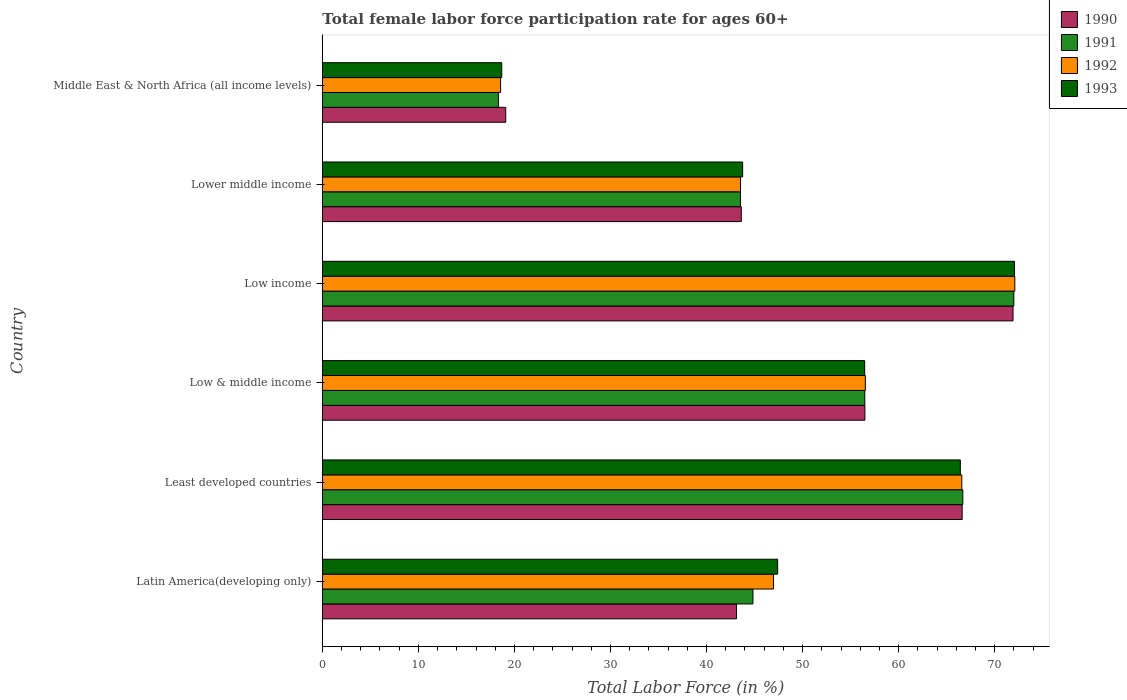How many groups of bars are there?
Keep it short and to the point. 6. Are the number of bars per tick equal to the number of legend labels?
Offer a very short reply. Yes. What is the label of the 5th group of bars from the top?
Offer a terse response. Least developed countries. What is the female labor force participation rate in 1992 in Lower middle income?
Keep it short and to the point. 43.54. Across all countries, what is the maximum female labor force participation rate in 1993?
Your answer should be very brief. 72.06. Across all countries, what is the minimum female labor force participation rate in 1993?
Keep it short and to the point. 18.68. In which country was the female labor force participation rate in 1993 maximum?
Your answer should be very brief. Low income. In which country was the female labor force participation rate in 1992 minimum?
Provide a short and direct response. Middle East & North Africa (all income levels). What is the total female labor force participation rate in 1990 in the graph?
Keep it short and to the point. 300.82. What is the difference between the female labor force participation rate in 1991 in Least developed countries and that in Middle East & North Africa (all income levels)?
Your answer should be compact. 48.35. What is the difference between the female labor force participation rate in 1992 in Latin America(developing only) and the female labor force participation rate in 1993 in Lower middle income?
Provide a short and direct response. 3.22. What is the average female labor force participation rate in 1992 per country?
Offer a terse response. 50.71. What is the difference between the female labor force participation rate in 1990 and female labor force participation rate in 1993 in Latin America(developing only)?
Give a very brief answer. -4.28. In how many countries, is the female labor force participation rate in 1993 greater than 20 %?
Provide a short and direct response. 5. What is the ratio of the female labor force participation rate in 1992 in Latin America(developing only) to that in Low income?
Your response must be concise. 0.65. Is the female labor force participation rate in 1992 in Lower middle income less than that in Middle East & North Africa (all income levels)?
Keep it short and to the point. No. Is the difference between the female labor force participation rate in 1990 in Lower middle income and Middle East & North Africa (all income levels) greater than the difference between the female labor force participation rate in 1993 in Lower middle income and Middle East & North Africa (all income levels)?
Provide a succinct answer. No. What is the difference between the highest and the second highest female labor force participation rate in 1992?
Offer a terse response. 5.52. What is the difference between the highest and the lowest female labor force participation rate in 1993?
Your answer should be compact. 53.38. In how many countries, is the female labor force participation rate in 1992 greater than the average female labor force participation rate in 1992 taken over all countries?
Offer a very short reply. 3. What does the 3rd bar from the top in Low income represents?
Provide a short and direct response. 1991. What does the 4th bar from the bottom in Low & middle income represents?
Offer a very short reply. 1993. How many bars are there?
Give a very brief answer. 24. What is the difference between two consecutive major ticks on the X-axis?
Ensure brevity in your answer.  10. Does the graph contain grids?
Make the answer very short. No. Where does the legend appear in the graph?
Ensure brevity in your answer.  Top right. How many legend labels are there?
Provide a succinct answer. 4. How are the legend labels stacked?
Keep it short and to the point. Vertical. What is the title of the graph?
Provide a succinct answer. Total female labor force participation rate for ages 60+. Does "2010" appear as one of the legend labels in the graph?
Ensure brevity in your answer.  No. What is the label or title of the X-axis?
Keep it short and to the point. Total Labor Force (in %). What is the Total Labor Force (in %) of 1990 in Latin America(developing only)?
Your answer should be very brief. 43.12. What is the Total Labor Force (in %) of 1991 in Latin America(developing only)?
Your response must be concise. 44.83. What is the Total Labor Force (in %) of 1992 in Latin America(developing only)?
Your answer should be very brief. 46.97. What is the Total Labor Force (in %) in 1993 in Latin America(developing only)?
Give a very brief answer. 47.4. What is the Total Labor Force (in %) of 1990 in Least developed countries?
Give a very brief answer. 66.61. What is the Total Labor Force (in %) of 1991 in Least developed countries?
Offer a terse response. 66.68. What is the Total Labor Force (in %) of 1992 in Least developed countries?
Provide a succinct answer. 66.57. What is the Total Labor Force (in %) in 1993 in Least developed countries?
Give a very brief answer. 66.42. What is the Total Labor Force (in %) in 1990 in Low & middle income?
Give a very brief answer. 56.48. What is the Total Labor Force (in %) in 1991 in Low & middle income?
Offer a very short reply. 56.47. What is the Total Labor Force (in %) of 1992 in Low & middle income?
Provide a short and direct response. 56.53. What is the Total Labor Force (in %) in 1993 in Low & middle income?
Offer a terse response. 56.46. What is the Total Labor Force (in %) of 1990 in Low income?
Your answer should be very brief. 71.9. What is the Total Labor Force (in %) of 1991 in Low income?
Provide a short and direct response. 71.99. What is the Total Labor Force (in %) in 1992 in Low income?
Offer a very short reply. 72.09. What is the Total Labor Force (in %) of 1993 in Low income?
Your answer should be compact. 72.06. What is the Total Labor Force (in %) in 1990 in Lower middle income?
Offer a terse response. 43.62. What is the Total Labor Force (in %) in 1991 in Lower middle income?
Your answer should be very brief. 43.53. What is the Total Labor Force (in %) in 1992 in Lower middle income?
Ensure brevity in your answer.  43.54. What is the Total Labor Force (in %) of 1993 in Lower middle income?
Keep it short and to the point. 43.76. What is the Total Labor Force (in %) in 1990 in Middle East & North Africa (all income levels)?
Your answer should be very brief. 19.09. What is the Total Labor Force (in %) of 1991 in Middle East & North Africa (all income levels)?
Provide a short and direct response. 18.33. What is the Total Labor Force (in %) of 1992 in Middle East & North Africa (all income levels)?
Ensure brevity in your answer.  18.56. What is the Total Labor Force (in %) in 1993 in Middle East & North Africa (all income levels)?
Your response must be concise. 18.68. Across all countries, what is the maximum Total Labor Force (in %) in 1990?
Your answer should be compact. 71.9. Across all countries, what is the maximum Total Labor Force (in %) of 1991?
Your answer should be compact. 71.99. Across all countries, what is the maximum Total Labor Force (in %) of 1992?
Give a very brief answer. 72.09. Across all countries, what is the maximum Total Labor Force (in %) in 1993?
Your answer should be compact. 72.06. Across all countries, what is the minimum Total Labor Force (in %) in 1990?
Offer a terse response. 19.09. Across all countries, what is the minimum Total Labor Force (in %) of 1991?
Provide a short and direct response. 18.33. Across all countries, what is the minimum Total Labor Force (in %) of 1992?
Provide a succinct answer. 18.56. Across all countries, what is the minimum Total Labor Force (in %) of 1993?
Offer a terse response. 18.68. What is the total Total Labor Force (in %) of 1990 in the graph?
Ensure brevity in your answer.  300.82. What is the total Total Labor Force (in %) of 1991 in the graph?
Ensure brevity in your answer.  301.83. What is the total Total Labor Force (in %) of 1992 in the graph?
Ensure brevity in your answer.  304.26. What is the total Total Labor Force (in %) in 1993 in the graph?
Give a very brief answer. 304.77. What is the difference between the Total Labor Force (in %) in 1990 in Latin America(developing only) and that in Least developed countries?
Ensure brevity in your answer.  -23.49. What is the difference between the Total Labor Force (in %) of 1991 in Latin America(developing only) and that in Least developed countries?
Provide a succinct answer. -21.85. What is the difference between the Total Labor Force (in %) of 1992 in Latin America(developing only) and that in Least developed countries?
Give a very brief answer. -19.6. What is the difference between the Total Labor Force (in %) of 1993 in Latin America(developing only) and that in Least developed countries?
Give a very brief answer. -19.02. What is the difference between the Total Labor Force (in %) of 1990 in Latin America(developing only) and that in Low & middle income?
Your answer should be compact. -13.36. What is the difference between the Total Labor Force (in %) in 1991 in Latin America(developing only) and that in Low & middle income?
Your response must be concise. -11.64. What is the difference between the Total Labor Force (in %) of 1992 in Latin America(developing only) and that in Low & middle income?
Keep it short and to the point. -9.56. What is the difference between the Total Labor Force (in %) in 1993 in Latin America(developing only) and that in Low & middle income?
Your answer should be very brief. -9.06. What is the difference between the Total Labor Force (in %) of 1990 in Latin America(developing only) and that in Low income?
Make the answer very short. -28.78. What is the difference between the Total Labor Force (in %) of 1991 in Latin America(developing only) and that in Low income?
Ensure brevity in your answer.  -27.16. What is the difference between the Total Labor Force (in %) in 1992 in Latin America(developing only) and that in Low income?
Ensure brevity in your answer.  -25.12. What is the difference between the Total Labor Force (in %) of 1993 in Latin America(developing only) and that in Low income?
Provide a short and direct response. -24.66. What is the difference between the Total Labor Force (in %) in 1990 in Latin America(developing only) and that in Lower middle income?
Make the answer very short. -0.5. What is the difference between the Total Labor Force (in %) of 1991 in Latin America(developing only) and that in Lower middle income?
Provide a short and direct response. 1.3. What is the difference between the Total Labor Force (in %) in 1992 in Latin America(developing only) and that in Lower middle income?
Make the answer very short. 3.44. What is the difference between the Total Labor Force (in %) of 1993 in Latin America(developing only) and that in Lower middle income?
Keep it short and to the point. 3.64. What is the difference between the Total Labor Force (in %) of 1990 in Latin America(developing only) and that in Middle East & North Africa (all income levels)?
Make the answer very short. 24.03. What is the difference between the Total Labor Force (in %) of 1991 in Latin America(developing only) and that in Middle East & North Africa (all income levels)?
Give a very brief answer. 26.5. What is the difference between the Total Labor Force (in %) of 1992 in Latin America(developing only) and that in Middle East & North Africa (all income levels)?
Your answer should be very brief. 28.42. What is the difference between the Total Labor Force (in %) of 1993 in Latin America(developing only) and that in Middle East & North Africa (all income levels)?
Provide a short and direct response. 28.72. What is the difference between the Total Labor Force (in %) in 1990 in Least developed countries and that in Low & middle income?
Make the answer very short. 10.12. What is the difference between the Total Labor Force (in %) in 1991 in Least developed countries and that in Low & middle income?
Your answer should be compact. 10.21. What is the difference between the Total Labor Force (in %) of 1992 in Least developed countries and that in Low & middle income?
Offer a terse response. 10.04. What is the difference between the Total Labor Force (in %) in 1993 in Least developed countries and that in Low & middle income?
Your answer should be very brief. 9.96. What is the difference between the Total Labor Force (in %) of 1990 in Least developed countries and that in Low income?
Provide a short and direct response. -5.3. What is the difference between the Total Labor Force (in %) in 1991 in Least developed countries and that in Low income?
Give a very brief answer. -5.31. What is the difference between the Total Labor Force (in %) in 1992 in Least developed countries and that in Low income?
Offer a terse response. -5.52. What is the difference between the Total Labor Force (in %) in 1993 in Least developed countries and that in Low income?
Your answer should be compact. -5.64. What is the difference between the Total Labor Force (in %) in 1990 in Least developed countries and that in Lower middle income?
Make the answer very short. 22.99. What is the difference between the Total Labor Force (in %) in 1991 in Least developed countries and that in Lower middle income?
Give a very brief answer. 23.15. What is the difference between the Total Labor Force (in %) in 1992 in Least developed countries and that in Lower middle income?
Offer a terse response. 23.04. What is the difference between the Total Labor Force (in %) in 1993 in Least developed countries and that in Lower middle income?
Offer a very short reply. 22.66. What is the difference between the Total Labor Force (in %) in 1990 in Least developed countries and that in Middle East & North Africa (all income levels)?
Give a very brief answer. 47.52. What is the difference between the Total Labor Force (in %) of 1991 in Least developed countries and that in Middle East & North Africa (all income levels)?
Keep it short and to the point. 48.35. What is the difference between the Total Labor Force (in %) of 1992 in Least developed countries and that in Middle East & North Africa (all income levels)?
Make the answer very short. 48.02. What is the difference between the Total Labor Force (in %) of 1993 in Least developed countries and that in Middle East & North Africa (all income levels)?
Provide a short and direct response. 47.74. What is the difference between the Total Labor Force (in %) in 1990 in Low & middle income and that in Low income?
Ensure brevity in your answer.  -15.42. What is the difference between the Total Labor Force (in %) of 1991 in Low & middle income and that in Low income?
Offer a very short reply. -15.52. What is the difference between the Total Labor Force (in %) in 1992 in Low & middle income and that in Low income?
Provide a short and direct response. -15.56. What is the difference between the Total Labor Force (in %) in 1993 in Low & middle income and that in Low income?
Your response must be concise. -15.6. What is the difference between the Total Labor Force (in %) of 1990 in Low & middle income and that in Lower middle income?
Your answer should be compact. 12.87. What is the difference between the Total Labor Force (in %) in 1991 in Low & middle income and that in Lower middle income?
Ensure brevity in your answer.  12.94. What is the difference between the Total Labor Force (in %) of 1992 in Low & middle income and that in Lower middle income?
Ensure brevity in your answer.  12.99. What is the difference between the Total Labor Force (in %) of 1993 in Low & middle income and that in Lower middle income?
Give a very brief answer. 12.7. What is the difference between the Total Labor Force (in %) of 1990 in Low & middle income and that in Middle East & North Africa (all income levels)?
Ensure brevity in your answer.  37.39. What is the difference between the Total Labor Force (in %) in 1991 in Low & middle income and that in Middle East & North Africa (all income levels)?
Your answer should be very brief. 38.14. What is the difference between the Total Labor Force (in %) of 1992 in Low & middle income and that in Middle East & North Africa (all income levels)?
Provide a short and direct response. 37.97. What is the difference between the Total Labor Force (in %) in 1993 in Low & middle income and that in Middle East & North Africa (all income levels)?
Offer a terse response. 37.78. What is the difference between the Total Labor Force (in %) in 1990 in Low income and that in Lower middle income?
Keep it short and to the point. 28.29. What is the difference between the Total Labor Force (in %) of 1991 in Low income and that in Lower middle income?
Your response must be concise. 28.46. What is the difference between the Total Labor Force (in %) in 1992 in Low income and that in Lower middle income?
Offer a terse response. 28.55. What is the difference between the Total Labor Force (in %) of 1993 in Low income and that in Lower middle income?
Offer a very short reply. 28.3. What is the difference between the Total Labor Force (in %) of 1990 in Low income and that in Middle East & North Africa (all income levels)?
Make the answer very short. 52.81. What is the difference between the Total Labor Force (in %) in 1991 in Low income and that in Middle East & North Africa (all income levels)?
Your answer should be compact. 53.66. What is the difference between the Total Labor Force (in %) in 1992 in Low income and that in Middle East & North Africa (all income levels)?
Give a very brief answer. 53.53. What is the difference between the Total Labor Force (in %) of 1993 in Low income and that in Middle East & North Africa (all income levels)?
Offer a very short reply. 53.38. What is the difference between the Total Labor Force (in %) in 1990 in Lower middle income and that in Middle East & North Africa (all income levels)?
Offer a terse response. 24.53. What is the difference between the Total Labor Force (in %) of 1991 in Lower middle income and that in Middle East & North Africa (all income levels)?
Offer a terse response. 25.2. What is the difference between the Total Labor Force (in %) of 1992 in Lower middle income and that in Middle East & North Africa (all income levels)?
Provide a succinct answer. 24.98. What is the difference between the Total Labor Force (in %) of 1993 in Lower middle income and that in Middle East & North Africa (all income levels)?
Give a very brief answer. 25.08. What is the difference between the Total Labor Force (in %) of 1990 in Latin America(developing only) and the Total Labor Force (in %) of 1991 in Least developed countries?
Make the answer very short. -23.56. What is the difference between the Total Labor Force (in %) of 1990 in Latin America(developing only) and the Total Labor Force (in %) of 1992 in Least developed countries?
Your answer should be compact. -23.45. What is the difference between the Total Labor Force (in %) of 1990 in Latin America(developing only) and the Total Labor Force (in %) of 1993 in Least developed countries?
Ensure brevity in your answer.  -23.3. What is the difference between the Total Labor Force (in %) in 1991 in Latin America(developing only) and the Total Labor Force (in %) in 1992 in Least developed countries?
Offer a terse response. -21.74. What is the difference between the Total Labor Force (in %) in 1991 in Latin America(developing only) and the Total Labor Force (in %) in 1993 in Least developed countries?
Keep it short and to the point. -21.59. What is the difference between the Total Labor Force (in %) of 1992 in Latin America(developing only) and the Total Labor Force (in %) of 1993 in Least developed countries?
Your answer should be compact. -19.45. What is the difference between the Total Labor Force (in %) of 1990 in Latin America(developing only) and the Total Labor Force (in %) of 1991 in Low & middle income?
Offer a very short reply. -13.35. What is the difference between the Total Labor Force (in %) of 1990 in Latin America(developing only) and the Total Labor Force (in %) of 1992 in Low & middle income?
Make the answer very short. -13.41. What is the difference between the Total Labor Force (in %) in 1990 in Latin America(developing only) and the Total Labor Force (in %) in 1993 in Low & middle income?
Your response must be concise. -13.34. What is the difference between the Total Labor Force (in %) of 1991 in Latin America(developing only) and the Total Labor Force (in %) of 1992 in Low & middle income?
Your answer should be very brief. -11.7. What is the difference between the Total Labor Force (in %) of 1991 in Latin America(developing only) and the Total Labor Force (in %) of 1993 in Low & middle income?
Offer a very short reply. -11.63. What is the difference between the Total Labor Force (in %) of 1992 in Latin America(developing only) and the Total Labor Force (in %) of 1993 in Low & middle income?
Your answer should be compact. -9.49. What is the difference between the Total Labor Force (in %) in 1990 in Latin America(developing only) and the Total Labor Force (in %) in 1991 in Low income?
Your response must be concise. -28.87. What is the difference between the Total Labor Force (in %) in 1990 in Latin America(developing only) and the Total Labor Force (in %) in 1992 in Low income?
Keep it short and to the point. -28.97. What is the difference between the Total Labor Force (in %) in 1990 in Latin America(developing only) and the Total Labor Force (in %) in 1993 in Low income?
Ensure brevity in your answer.  -28.94. What is the difference between the Total Labor Force (in %) in 1991 in Latin America(developing only) and the Total Labor Force (in %) in 1992 in Low income?
Provide a succinct answer. -27.26. What is the difference between the Total Labor Force (in %) in 1991 in Latin America(developing only) and the Total Labor Force (in %) in 1993 in Low income?
Provide a succinct answer. -27.23. What is the difference between the Total Labor Force (in %) of 1992 in Latin America(developing only) and the Total Labor Force (in %) of 1993 in Low income?
Offer a very short reply. -25.09. What is the difference between the Total Labor Force (in %) in 1990 in Latin America(developing only) and the Total Labor Force (in %) in 1991 in Lower middle income?
Provide a short and direct response. -0.41. What is the difference between the Total Labor Force (in %) in 1990 in Latin America(developing only) and the Total Labor Force (in %) in 1992 in Lower middle income?
Make the answer very short. -0.42. What is the difference between the Total Labor Force (in %) of 1990 in Latin America(developing only) and the Total Labor Force (in %) of 1993 in Lower middle income?
Ensure brevity in your answer.  -0.64. What is the difference between the Total Labor Force (in %) in 1991 in Latin America(developing only) and the Total Labor Force (in %) in 1992 in Lower middle income?
Your answer should be compact. 1.29. What is the difference between the Total Labor Force (in %) of 1991 in Latin America(developing only) and the Total Labor Force (in %) of 1993 in Lower middle income?
Your response must be concise. 1.07. What is the difference between the Total Labor Force (in %) of 1992 in Latin America(developing only) and the Total Labor Force (in %) of 1993 in Lower middle income?
Offer a very short reply. 3.22. What is the difference between the Total Labor Force (in %) of 1990 in Latin America(developing only) and the Total Labor Force (in %) of 1991 in Middle East & North Africa (all income levels)?
Offer a very short reply. 24.79. What is the difference between the Total Labor Force (in %) of 1990 in Latin America(developing only) and the Total Labor Force (in %) of 1992 in Middle East & North Africa (all income levels)?
Your response must be concise. 24.56. What is the difference between the Total Labor Force (in %) in 1990 in Latin America(developing only) and the Total Labor Force (in %) in 1993 in Middle East & North Africa (all income levels)?
Provide a short and direct response. 24.44. What is the difference between the Total Labor Force (in %) of 1991 in Latin America(developing only) and the Total Labor Force (in %) of 1992 in Middle East & North Africa (all income levels)?
Provide a succinct answer. 26.27. What is the difference between the Total Labor Force (in %) of 1991 in Latin America(developing only) and the Total Labor Force (in %) of 1993 in Middle East & North Africa (all income levels)?
Keep it short and to the point. 26.15. What is the difference between the Total Labor Force (in %) in 1992 in Latin America(developing only) and the Total Labor Force (in %) in 1993 in Middle East & North Africa (all income levels)?
Keep it short and to the point. 28.3. What is the difference between the Total Labor Force (in %) of 1990 in Least developed countries and the Total Labor Force (in %) of 1991 in Low & middle income?
Your answer should be very brief. 10.14. What is the difference between the Total Labor Force (in %) in 1990 in Least developed countries and the Total Labor Force (in %) in 1992 in Low & middle income?
Make the answer very short. 10.08. What is the difference between the Total Labor Force (in %) in 1990 in Least developed countries and the Total Labor Force (in %) in 1993 in Low & middle income?
Keep it short and to the point. 10.15. What is the difference between the Total Labor Force (in %) of 1991 in Least developed countries and the Total Labor Force (in %) of 1992 in Low & middle income?
Your answer should be compact. 10.15. What is the difference between the Total Labor Force (in %) in 1991 in Least developed countries and the Total Labor Force (in %) in 1993 in Low & middle income?
Your response must be concise. 10.22. What is the difference between the Total Labor Force (in %) of 1992 in Least developed countries and the Total Labor Force (in %) of 1993 in Low & middle income?
Make the answer very short. 10.11. What is the difference between the Total Labor Force (in %) of 1990 in Least developed countries and the Total Labor Force (in %) of 1991 in Low income?
Ensure brevity in your answer.  -5.38. What is the difference between the Total Labor Force (in %) of 1990 in Least developed countries and the Total Labor Force (in %) of 1992 in Low income?
Ensure brevity in your answer.  -5.48. What is the difference between the Total Labor Force (in %) of 1990 in Least developed countries and the Total Labor Force (in %) of 1993 in Low income?
Make the answer very short. -5.45. What is the difference between the Total Labor Force (in %) of 1991 in Least developed countries and the Total Labor Force (in %) of 1992 in Low income?
Your response must be concise. -5.41. What is the difference between the Total Labor Force (in %) in 1991 in Least developed countries and the Total Labor Force (in %) in 1993 in Low income?
Your answer should be compact. -5.38. What is the difference between the Total Labor Force (in %) in 1992 in Least developed countries and the Total Labor Force (in %) in 1993 in Low income?
Offer a terse response. -5.49. What is the difference between the Total Labor Force (in %) in 1990 in Least developed countries and the Total Labor Force (in %) in 1991 in Lower middle income?
Your answer should be very brief. 23.08. What is the difference between the Total Labor Force (in %) in 1990 in Least developed countries and the Total Labor Force (in %) in 1992 in Lower middle income?
Your answer should be very brief. 23.07. What is the difference between the Total Labor Force (in %) of 1990 in Least developed countries and the Total Labor Force (in %) of 1993 in Lower middle income?
Make the answer very short. 22.85. What is the difference between the Total Labor Force (in %) of 1991 in Least developed countries and the Total Labor Force (in %) of 1992 in Lower middle income?
Make the answer very short. 23.14. What is the difference between the Total Labor Force (in %) in 1991 in Least developed countries and the Total Labor Force (in %) in 1993 in Lower middle income?
Your answer should be compact. 22.92. What is the difference between the Total Labor Force (in %) in 1992 in Least developed countries and the Total Labor Force (in %) in 1993 in Lower middle income?
Provide a succinct answer. 22.82. What is the difference between the Total Labor Force (in %) in 1990 in Least developed countries and the Total Labor Force (in %) in 1991 in Middle East & North Africa (all income levels)?
Offer a terse response. 48.28. What is the difference between the Total Labor Force (in %) of 1990 in Least developed countries and the Total Labor Force (in %) of 1992 in Middle East & North Africa (all income levels)?
Ensure brevity in your answer.  48.05. What is the difference between the Total Labor Force (in %) in 1990 in Least developed countries and the Total Labor Force (in %) in 1993 in Middle East & North Africa (all income levels)?
Ensure brevity in your answer.  47.93. What is the difference between the Total Labor Force (in %) in 1991 in Least developed countries and the Total Labor Force (in %) in 1992 in Middle East & North Africa (all income levels)?
Offer a very short reply. 48.12. What is the difference between the Total Labor Force (in %) in 1991 in Least developed countries and the Total Labor Force (in %) in 1993 in Middle East & North Africa (all income levels)?
Your answer should be compact. 48. What is the difference between the Total Labor Force (in %) in 1992 in Least developed countries and the Total Labor Force (in %) in 1993 in Middle East & North Africa (all income levels)?
Your answer should be very brief. 47.9. What is the difference between the Total Labor Force (in %) of 1990 in Low & middle income and the Total Labor Force (in %) of 1991 in Low income?
Offer a terse response. -15.51. What is the difference between the Total Labor Force (in %) of 1990 in Low & middle income and the Total Labor Force (in %) of 1992 in Low income?
Provide a short and direct response. -15.61. What is the difference between the Total Labor Force (in %) of 1990 in Low & middle income and the Total Labor Force (in %) of 1993 in Low income?
Your answer should be very brief. -15.57. What is the difference between the Total Labor Force (in %) in 1991 in Low & middle income and the Total Labor Force (in %) in 1992 in Low income?
Offer a very short reply. -15.62. What is the difference between the Total Labor Force (in %) of 1991 in Low & middle income and the Total Labor Force (in %) of 1993 in Low income?
Give a very brief answer. -15.59. What is the difference between the Total Labor Force (in %) in 1992 in Low & middle income and the Total Labor Force (in %) in 1993 in Low income?
Ensure brevity in your answer.  -15.53. What is the difference between the Total Labor Force (in %) of 1990 in Low & middle income and the Total Labor Force (in %) of 1991 in Lower middle income?
Ensure brevity in your answer.  12.95. What is the difference between the Total Labor Force (in %) of 1990 in Low & middle income and the Total Labor Force (in %) of 1992 in Lower middle income?
Your answer should be compact. 12.95. What is the difference between the Total Labor Force (in %) of 1990 in Low & middle income and the Total Labor Force (in %) of 1993 in Lower middle income?
Your answer should be compact. 12.73. What is the difference between the Total Labor Force (in %) of 1991 in Low & middle income and the Total Labor Force (in %) of 1992 in Lower middle income?
Ensure brevity in your answer.  12.93. What is the difference between the Total Labor Force (in %) of 1991 in Low & middle income and the Total Labor Force (in %) of 1993 in Lower middle income?
Give a very brief answer. 12.71. What is the difference between the Total Labor Force (in %) in 1992 in Low & middle income and the Total Labor Force (in %) in 1993 in Lower middle income?
Your answer should be very brief. 12.77. What is the difference between the Total Labor Force (in %) in 1990 in Low & middle income and the Total Labor Force (in %) in 1991 in Middle East & North Africa (all income levels)?
Your response must be concise. 38.15. What is the difference between the Total Labor Force (in %) in 1990 in Low & middle income and the Total Labor Force (in %) in 1992 in Middle East & North Africa (all income levels)?
Keep it short and to the point. 37.93. What is the difference between the Total Labor Force (in %) of 1990 in Low & middle income and the Total Labor Force (in %) of 1993 in Middle East & North Africa (all income levels)?
Provide a succinct answer. 37.81. What is the difference between the Total Labor Force (in %) in 1991 in Low & middle income and the Total Labor Force (in %) in 1992 in Middle East & North Africa (all income levels)?
Keep it short and to the point. 37.91. What is the difference between the Total Labor Force (in %) in 1991 in Low & middle income and the Total Labor Force (in %) in 1993 in Middle East & North Africa (all income levels)?
Your response must be concise. 37.79. What is the difference between the Total Labor Force (in %) of 1992 in Low & middle income and the Total Labor Force (in %) of 1993 in Middle East & North Africa (all income levels)?
Give a very brief answer. 37.85. What is the difference between the Total Labor Force (in %) in 1990 in Low income and the Total Labor Force (in %) in 1991 in Lower middle income?
Ensure brevity in your answer.  28.37. What is the difference between the Total Labor Force (in %) in 1990 in Low income and the Total Labor Force (in %) in 1992 in Lower middle income?
Offer a very short reply. 28.37. What is the difference between the Total Labor Force (in %) of 1990 in Low income and the Total Labor Force (in %) of 1993 in Lower middle income?
Offer a terse response. 28.15. What is the difference between the Total Labor Force (in %) in 1991 in Low income and the Total Labor Force (in %) in 1992 in Lower middle income?
Keep it short and to the point. 28.45. What is the difference between the Total Labor Force (in %) of 1991 in Low income and the Total Labor Force (in %) of 1993 in Lower middle income?
Offer a terse response. 28.23. What is the difference between the Total Labor Force (in %) in 1992 in Low income and the Total Labor Force (in %) in 1993 in Lower middle income?
Keep it short and to the point. 28.33. What is the difference between the Total Labor Force (in %) of 1990 in Low income and the Total Labor Force (in %) of 1991 in Middle East & North Africa (all income levels)?
Your answer should be very brief. 53.57. What is the difference between the Total Labor Force (in %) of 1990 in Low income and the Total Labor Force (in %) of 1992 in Middle East & North Africa (all income levels)?
Offer a very short reply. 53.35. What is the difference between the Total Labor Force (in %) in 1990 in Low income and the Total Labor Force (in %) in 1993 in Middle East & North Africa (all income levels)?
Provide a short and direct response. 53.23. What is the difference between the Total Labor Force (in %) of 1991 in Low income and the Total Labor Force (in %) of 1992 in Middle East & North Africa (all income levels)?
Keep it short and to the point. 53.43. What is the difference between the Total Labor Force (in %) of 1991 in Low income and the Total Labor Force (in %) of 1993 in Middle East & North Africa (all income levels)?
Provide a short and direct response. 53.31. What is the difference between the Total Labor Force (in %) in 1992 in Low income and the Total Labor Force (in %) in 1993 in Middle East & North Africa (all income levels)?
Provide a succinct answer. 53.41. What is the difference between the Total Labor Force (in %) in 1990 in Lower middle income and the Total Labor Force (in %) in 1991 in Middle East & North Africa (all income levels)?
Your response must be concise. 25.29. What is the difference between the Total Labor Force (in %) in 1990 in Lower middle income and the Total Labor Force (in %) in 1992 in Middle East & North Africa (all income levels)?
Offer a terse response. 25.06. What is the difference between the Total Labor Force (in %) of 1990 in Lower middle income and the Total Labor Force (in %) of 1993 in Middle East & North Africa (all income levels)?
Your response must be concise. 24.94. What is the difference between the Total Labor Force (in %) in 1991 in Lower middle income and the Total Labor Force (in %) in 1992 in Middle East & North Africa (all income levels)?
Make the answer very short. 24.97. What is the difference between the Total Labor Force (in %) in 1991 in Lower middle income and the Total Labor Force (in %) in 1993 in Middle East & North Africa (all income levels)?
Keep it short and to the point. 24.85. What is the difference between the Total Labor Force (in %) of 1992 in Lower middle income and the Total Labor Force (in %) of 1993 in Middle East & North Africa (all income levels)?
Offer a very short reply. 24.86. What is the average Total Labor Force (in %) in 1990 per country?
Offer a very short reply. 50.14. What is the average Total Labor Force (in %) of 1991 per country?
Offer a terse response. 50.3. What is the average Total Labor Force (in %) of 1992 per country?
Offer a very short reply. 50.71. What is the average Total Labor Force (in %) in 1993 per country?
Your response must be concise. 50.79. What is the difference between the Total Labor Force (in %) of 1990 and Total Labor Force (in %) of 1991 in Latin America(developing only)?
Provide a succinct answer. -1.71. What is the difference between the Total Labor Force (in %) of 1990 and Total Labor Force (in %) of 1992 in Latin America(developing only)?
Make the answer very short. -3.85. What is the difference between the Total Labor Force (in %) in 1990 and Total Labor Force (in %) in 1993 in Latin America(developing only)?
Ensure brevity in your answer.  -4.28. What is the difference between the Total Labor Force (in %) in 1991 and Total Labor Force (in %) in 1992 in Latin America(developing only)?
Your answer should be compact. -2.14. What is the difference between the Total Labor Force (in %) of 1991 and Total Labor Force (in %) of 1993 in Latin America(developing only)?
Offer a very short reply. -2.57. What is the difference between the Total Labor Force (in %) of 1992 and Total Labor Force (in %) of 1993 in Latin America(developing only)?
Your response must be concise. -0.43. What is the difference between the Total Labor Force (in %) in 1990 and Total Labor Force (in %) in 1991 in Least developed countries?
Your answer should be very brief. -0.07. What is the difference between the Total Labor Force (in %) of 1990 and Total Labor Force (in %) of 1992 in Least developed countries?
Your answer should be very brief. 0.03. What is the difference between the Total Labor Force (in %) of 1990 and Total Labor Force (in %) of 1993 in Least developed countries?
Make the answer very short. 0.19. What is the difference between the Total Labor Force (in %) of 1991 and Total Labor Force (in %) of 1992 in Least developed countries?
Keep it short and to the point. 0.1. What is the difference between the Total Labor Force (in %) in 1991 and Total Labor Force (in %) in 1993 in Least developed countries?
Offer a very short reply. 0.26. What is the difference between the Total Labor Force (in %) of 1992 and Total Labor Force (in %) of 1993 in Least developed countries?
Your response must be concise. 0.16. What is the difference between the Total Labor Force (in %) of 1990 and Total Labor Force (in %) of 1991 in Low & middle income?
Your answer should be compact. 0.01. What is the difference between the Total Labor Force (in %) of 1990 and Total Labor Force (in %) of 1992 in Low & middle income?
Give a very brief answer. -0.05. What is the difference between the Total Labor Force (in %) in 1990 and Total Labor Force (in %) in 1993 in Low & middle income?
Give a very brief answer. 0.02. What is the difference between the Total Labor Force (in %) in 1991 and Total Labor Force (in %) in 1992 in Low & middle income?
Make the answer very short. -0.06. What is the difference between the Total Labor Force (in %) in 1991 and Total Labor Force (in %) in 1993 in Low & middle income?
Offer a very short reply. 0.01. What is the difference between the Total Labor Force (in %) in 1992 and Total Labor Force (in %) in 1993 in Low & middle income?
Your answer should be very brief. 0.07. What is the difference between the Total Labor Force (in %) of 1990 and Total Labor Force (in %) of 1991 in Low income?
Your answer should be very brief. -0.09. What is the difference between the Total Labor Force (in %) in 1990 and Total Labor Force (in %) in 1992 in Low income?
Your answer should be very brief. -0.18. What is the difference between the Total Labor Force (in %) of 1990 and Total Labor Force (in %) of 1993 in Low income?
Offer a very short reply. -0.15. What is the difference between the Total Labor Force (in %) of 1991 and Total Labor Force (in %) of 1992 in Low income?
Keep it short and to the point. -0.1. What is the difference between the Total Labor Force (in %) of 1991 and Total Labor Force (in %) of 1993 in Low income?
Your answer should be very brief. -0.07. What is the difference between the Total Labor Force (in %) in 1992 and Total Labor Force (in %) in 1993 in Low income?
Your answer should be very brief. 0.03. What is the difference between the Total Labor Force (in %) of 1990 and Total Labor Force (in %) of 1991 in Lower middle income?
Your answer should be compact. 0.09. What is the difference between the Total Labor Force (in %) of 1990 and Total Labor Force (in %) of 1992 in Lower middle income?
Your answer should be compact. 0.08. What is the difference between the Total Labor Force (in %) in 1990 and Total Labor Force (in %) in 1993 in Lower middle income?
Keep it short and to the point. -0.14. What is the difference between the Total Labor Force (in %) in 1991 and Total Labor Force (in %) in 1992 in Lower middle income?
Give a very brief answer. -0.01. What is the difference between the Total Labor Force (in %) of 1991 and Total Labor Force (in %) of 1993 in Lower middle income?
Provide a short and direct response. -0.23. What is the difference between the Total Labor Force (in %) in 1992 and Total Labor Force (in %) in 1993 in Lower middle income?
Your answer should be compact. -0.22. What is the difference between the Total Labor Force (in %) in 1990 and Total Labor Force (in %) in 1991 in Middle East & North Africa (all income levels)?
Provide a succinct answer. 0.76. What is the difference between the Total Labor Force (in %) of 1990 and Total Labor Force (in %) of 1992 in Middle East & North Africa (all income levels)?
Provide a succinct answer. 0.53. What is the difference between the Total Labor Force (in %) in 1990 and Total Labor Force (in %) in 1993 in Middle East & North Africa (all income levels)?
Your answer should be very brief. 0.41. What is the difference between the Total Labor Force (in %) of 1991 and Total Labor Force (in %) of 1992 in Middle East & North Africa (all income levels)?
Make the answer very short. -0.23. What is the difference between the Total Labor Force (in %) of 1991 and Total Labor Force (in %) of 1993 in Middle East & North Africa (all income levels)?
Make the answer very short. -0.35. What is the difference between the Total Labor Force (in %) of 1992 and Total Labor Force (in %) of 1993 in Middle East & North Africa (all income levels)?
Make the answer very short. -0.12. What is the ratio of the Total Labor Force (in %) in 1990 in Latin America(developing only) to that in Least developed countries?
Your answer should be very brief. 0.65. What is the ratio of the Total Labor Force (in %) of 1991 in Latin America(developing only) to that in Least developed countries?
Ensure brevity in your answer.  0.67. What is the ratio of the Total Labor Force (in %) in 1992 in Latin America(developing only) to that in Least developed countries?
Ensure brevity in your answer.  0.71. What is the ratio of the Total Labor Force (in %) of 1993 in Latin America(developing only) to that in Least developed countries?
Ensure brevity in your answer.  0.71. What is the ratio of the Total Labor Force (in %) of 1990 in Latin America(developing only) to that in Low & middle income?
Your answer should be compact. 0.76. What is the ratio of the Total Labor Force (in %) of 1991 in Latin America(developing only) to that in Low & middle income?
Your answer should be very brief. 0.79. What is the ratio of the Total Labor Force (in %) of 1992 in Latin America(developing only) to that in Low & middle income?
Provide a succinct answer. 0.83. What is the ratio of the Total Labor Force (in %) in 1993 in Latin America(developing only) to that in Low & middle income?
Provide a short and direct response. 0.84. What is the ratio of the Total Labor Force (in %) in 1990 in Latin America(developing only) to that in Low income?
Your response must be concise. 0.6. What is the ratio of the Total Labor Force (in %) of 1991 in Latin America(developing only) to that in Low income?
Provide a succinct answer. 0.62. What is the ratio of the Total Labor Force (in %) in 1992 in Latin America(developing only) to that in Low income?
Offer a terse response. 0.65. What is the ratio of the Total Labor Force (in %) in 1993 in Latin America(developing only) to that in Low income?
Offer a terse response. 0.66. What is the ratio of the Total Labor Force (in %) in 1990 in Latin America(developing only) to that in Lower middle income?
Give a very brief answer. 0.99. What is the ratio of the Total Labor Force (in %) of 1991 in Latin America(developing only) to that in Lower middle income?
Make the answer very short. 1.03. What is the ratio of the Total Labor Force (in %) in 1992 in Latin America(developing only) to that in Lower middle income?
Your response must be concise. 1.08. What is the ratio of the Total Labor Force (in %) in 1990 in Latin America(developing only) to that in Middle East & North Africa (all income levels)?
Offer a terse response. 2.26. What is the ratio of the Total Labor Force (in %) in 1991 in Latin America(developing only) to that in Middle East & North Africa (all income levels)?
Your response must be concise. 2.45. What is the ratio of the Total Labor Force (in %) in 1992 in Latin America(developing only) to that in Middle East & North Africa (all income levels)?
Offer a very short reply. 2.53. What is the ratio of the Total Labor Force (in %) of 1993 in Latin America(developing only) to that in Middle East & North Africa (all income levels)?
Provide a short and direct response. 2.54. What is the ratio of the Total Labor Force (in %) in 1990 in Least developed countries to that in Low & middle income?
Offer a terse response. 1.18. What is the ratio of the Total Labor Force (in %) of 1991 in Least developed countries to that in Low & middle income?
Your response must be concise. 1.18. What is the ratio of the Total Labor Force (in %) in 1992 in Least developed countries to that in Low & middle income?
Provide a succinct answer. 1.18. What is the ratio of the Total Labor Force (in %) in 1993 in Least developed countries to that in Low & middle income?
Offer a very short reply. 1.18. What is the ratio of the Total Labor Force (in %) in 1990 in Least developed countries to that in Low income?
Your answer should be very brief. 0.93. What is the ratio of the Total Labor Force (in %) in 1991 in Least developed countries to that in Low income?
Provide a short and direct response. 0.93. What is the ratio of the Total Labor Force (in %) in 1992 in Least developed countries to that in Low income?
Give a very brief answer. 0.92. What is the ratio of the Total Labor Force (in %) in 1993 in Least developed countries to that in Low income?
Make the answer very short. 0.92. What is the ratio of the Total Labor Force (in %) of 1990 in Least developed countries to that in Lower middle income?
Your response must be concise. 1.53. What is the ratio of the Total Labor Force (in %) in 1991 in Least developed countries to that in Lower middle income?
Offer a terse response. 1.53. What is the ratio of the Total Labor Force (in %) in 1992 in Least developed countries to that in Lower middle income?
Your answer should be compact. 1.53. What is the ratio of the Total Labor Force (in %) in 1993 in Least developed countries to that in Lower middle income?
Your response must be concise. 1.52. What is the ratio of the Total Labor Force (in %) of 1990 in Least developed countries to that in Middle East & North Africa (all income levels)?
Your answer should be very brief. 3.49. What is the ratio of the Total Labor Force (in %) in 1991 in Least developed countries to that in Middle East & North Africa (all income levels)?
Provide a short and direct response. 3.64. What is the ratio of the Total Labor Force (in %) of 1992 in Least developed countries to that in Middle East & North Africa (all income levels)?
Ensure brevity in your answer.  3.59. What is the ratio of the Total Labor Force (in %) of 1993 in Least developed countries to that in Middle East & North Africa (all income levels)?
Your answer should be very brief. 3.56. What is the ratio of the Total Labor Force (in %) in 1990 in Low & middle income to that in Low income?
Provide a short and direct response. 0.79. What is the ratio of the Total Labor Force (in %) in 1991 in Low & middle income to that in Low income?
Your answer should be very brief. 0.78. What is the ratio of the Total Labor Force (in %) in 1992 in Low & middle income to that in Low income?
Ensure brevity in your answer.  0.78. What is the ratio of the Total Labor Force (in %) in 1993 in Low & middle income to that in Low income?
Offer a terse response. 0.78. What is the ratio of the Total Labor Force (in %) in 1990 in Low & middle income to that in Lower middle income?
Your answer should be very brief. 1.29. What is the ratio of the Total Labor Force (in %) in 1991 in Low & middle income to that in Lower middle income?
Give a very brief answer. 1.3. What is the ratio of the Total Labor Force (in %) in 1992 in Low & middle income to that in Lower middle income?
Make the answer very short. 1.3. What is the ratio of the Total Labor Force (in %) of 1993 in Low & middle income to that in Lower middle income?
Ensure brevity in your answer.  1.29. What is the ratio of the Total Labor Force (in %) in 1990 in Low & middle income to that in Middle East & North Africa (all income levels)?
Offer a very short reply. 2.96. What is the ratio of the Total Labor Force (in %) of 1991 in Low & middle income to that in Middle East & North Africa (all income levels)?
Keep it short and to the point. 3.08. What is the ratio of the Total Labor Force (in %) in 1992 in Low & middle income to that in Middle East & North Africa (all income levels)?
Give a very brief answer. 3.05. What is the ratio of the Total Labor Force (in %) of 1993 in Low & middle income to that in Middle East & North Africa (all income levels)?
Your answer should be very brief. 3.02. What is the ratio of the Total Labor Force (in %) in 1990 in Low income to that in Lower middle income?
Offer a very short reply. 1.65. What is the ratio of the Total Labor Force (in %) of 1991 in Low income to that in Lower middle income?
Keep it short and to the point. 1.65. What is the ratio of the Total Labor Force (in %) of 1992 in Low income to that in Lower middle income?
Keep it short and to the point. 1.66. What is the ratio of the Total Labor Force (in %) of 1993 in Low income to that in Lower middle income?
Provide a succinct answer. 1.65. What is the ratio of the Total Labor Force (in %) of 1990 in Low income to that in Middle East & North Africa (all income levels)?
Make the answer very short. 3.77. What is the ratio of the Total Labor Force (in %) in 1991 in Low income to that in Middle East & North Africa (all income levels)?
Your answer should be very brief. 3.93. What is the ratio of the Total Labor Force (in %) of 1992 in Low income to that in Middle East & North Africa (all income levels)?
Make the answer very short. 3.88. What is the ratio of the Total Labor Force (in %) of 1993 in Low income to that in Middle East & North Africa (all income levels)?
Provide a succinct answer. 3.86. What is the ratio of the Total Labor Force (in %) in 1990 in Lower middle income to that in Middle East & North Africa (all income levels)?
Provide a short and direct response. 2.28. What is the ratio of the Total Labor Force (in %) of 1991 in Lower middle income to that in Middle East & North Africa (all income levels)?
Provide a short and direct response. 2.37. What is the ratio of the Total Labor Force (in %) in 1992 in Lower middle income to that in Middle East & North Africa (all income levels)?
Ensure brevity in your answer.  2.35. What is the ratio of the Total Labor Force (in %) of 1993 in Lower middle income to that in Middle East & North Africa (all income levels)?
Your answer should be compact. 2.34. What is the difference between the highest and the second highest Total Labor Force (in %) of 1990?
Your response must be concise. 5.3. What is the difference between the highest and the second highest Total Labor Force (in %) of 1991?
Your response must be concise. 5.31. What is the difference between the highest and the second highest Total Labor Force (in %) of 1992?
Ensure brevity in your answer.  5.52. What is the difference between the highest and the second highest Total Labor Force (in %) in 1993?
Ensure brevity in your answer.  5.64. What is the difference between the highest and the lowest Total Labor Force (in %) in 1990?
Your answer should be very brief. 52.81. What is the difference between the highest and the lowest Total Labor Force (in %) of 1991?
Offer a very short reply. 53.66. What is the difference between the highest and the lowest Total Labor Force (in %) in 1992?
Keep it short and to the point. 53.53. What is the difference between the highest and the lowest Total Labor Force (in %) of 1993?
Give a very brief answer. 53.38. 